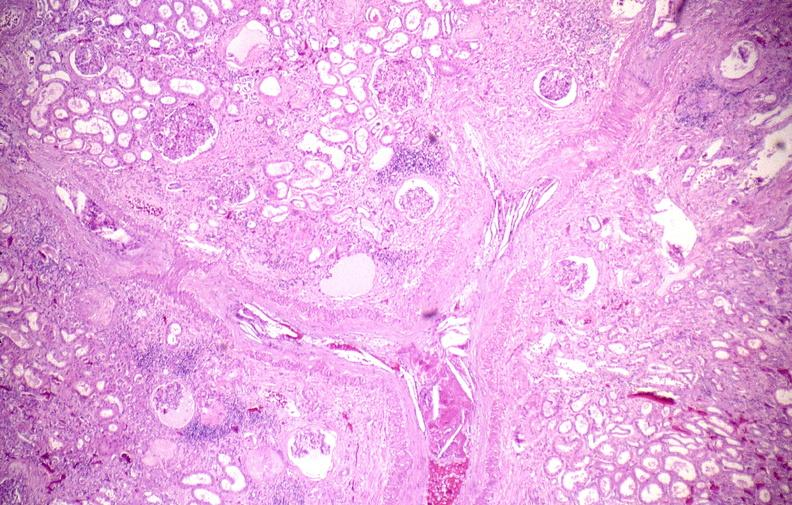does this image show atherosclerotic emboli?
Answer the question using a single word or phrase. Yes 